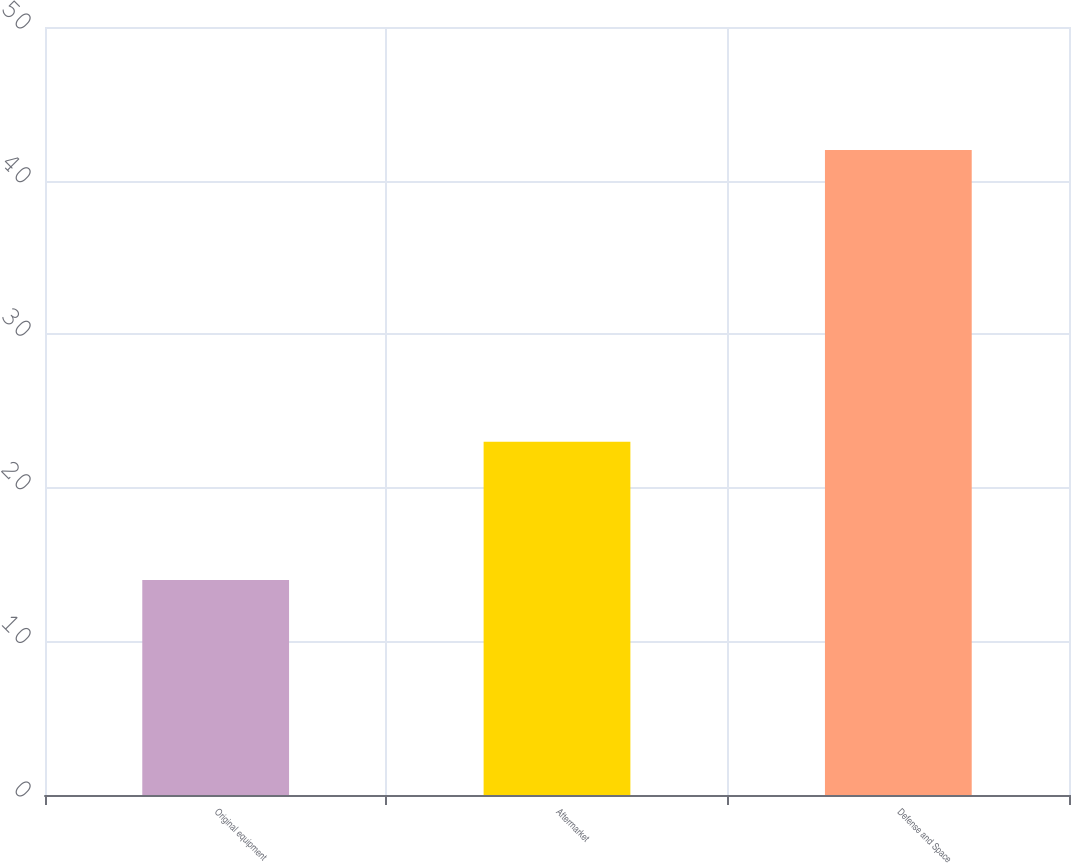<chart> <loc_0><loc_0><loc_500><loc_500><bar_chart><fcel>Original equipment<fcel>Aftermarket<fcel>Defense and Space<nl><fcel>14<fcel>23<fcel>42<nl></chart> 